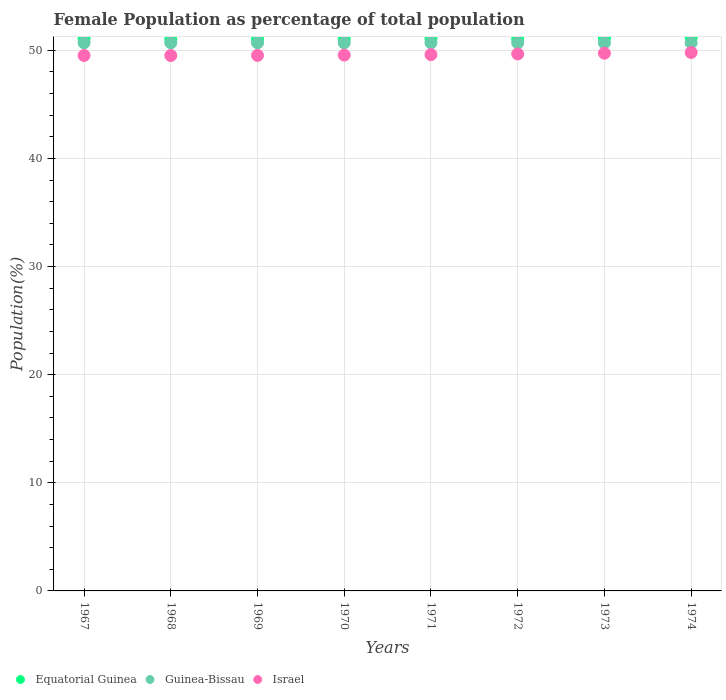How many different coloured dotlines are there?
Ensure brevity in your answer.  3. What is the female population in in Guinea-Bissau in 1967?
Provide a short and direct response. 50.69. Across all years, what is the maximum female population in in Guinea-Bissau?
Keep it short and to the point. 50.7. Across all years, what is the minimum female population in in Equatorial Guinea?
Ensure brevity in your answer.  51.02. In which year was the female population in in Equatorial Guinea maximum?
Provide a short and direct response. 1974. In which year was the female population in in Equatorial Guinea minimum?
Make the answer very short. 1968. What is the total female population in in Israel in the graph?
Your answer should be very brief. 396.96. What is the difference between the female population in in Israel in 1972 and that in 1973?
Offer a terse response. -0.07. What is the difference between the female population in in Guinea-Bissau in 1968 and the female population in in Israel in 1974?
Offer a very short reply. 0.89. What is the average female population in in Equatorial Guinea per year?
Your answer should be compact. 51.07. In the year 1967, what is the difference between the female population in in Equatorial Guinea and female population in in Guinea-Bissau?
Keep it short and to the point. 0.33. What is the ratio of the female population in in Guinea-Bissau in 1968 to that in 1974?
Provide a succinct answer. 1. What is the difference between the highest and the second highest female population in in Equatorial Guinea?
Your answer should be very brief. 0.06. What is the difference between the highest and the lowest female population in in Equatorial Guinea?
Offer a terse response. 0.18. In how many years, is the female population in in Israel greater than the average female population in in Israel taken over all years?
Your answer should be compact. 3. Is the sum of the female population in in Guinea-Bissau in 1970 and 1974 greater than the maximum female population in in Equatorial Guinea across all years?
Your answer should be very brief. Yes. Is the female population in in Guinea-Bissau strictly greater than the female population in in Israel over the years?
Your answer should be very brief. Yes. Is the female population in in Israel strictly less than the female population in in Guinea-Bissau over the years?
Offer a terse response. Yes. How many dotlines are there?
Keep it short and to the point. 3. Does the graph contain any zero values?
Give a very brief answer. No. Does the graph contain grids?
Give a very brief answer. Yes. Where does the legend appear in the graph?
Your response must be concise. Bottom left. How many legend labels are there?
Ensure brevity in your answer.  3. What is the title of the graph?
Your answer should be very brief. Female Population as percentage of total population. What is the label or title of the Y-axis?
Keep it short and to the point. Population(%). What is the Population(%) of Equatorial Guinea in 1967?
Provide a short and direct response. 51.02. What is the Population(%) in Guinea-Bissau in 1967?
Offer a terse response. 50.69. What is the Population(%) in Israel in 1967?
Offer a very short reply. 49.52. What is the Population(%) of Equatorial Guinea in 1968?
Make the answer very short. 51.02. What is the Population(%) of Guinea-Bissau in 1968?
Provide a short and direct response. 50.7. What is the Population(%) of Israel in 1968?
Offer a terse response. 49.52. What is the Population(%) of Equatorial Guinea in 1969?
Make the answer very short. 51.02. What is the Population(%) in Guinea-Bissau in 1969?
Offer a very short reply. 50.7. What is the Population(%) in Israel in 1969?
Provide a succinct answer. 49.53. What is the Population(%) in Equatorial Guinea in 1970?
Your answer should be compact. 51.03. What is the Population(%) of Guinea-Bissau in 1970?
Offer a terse response. 50.7. What is the Population(%) of Israel in 1970?
Ensure brevity in your answer.  49.56. What is the Population(%) in Equatorial Guinea in 1971?
Provide a succinct answer. 51.05. What is the Population(%) of Guinea-Bissau in 1971?
Give a very brief answer. 50.7. What is the Population(%) in Israel in 1971?
Your answer should be compact. 49.61. What is the Population(%) of Equatorial Guinea in 1972?
Ensure brevity in your answer.  51.08. What is the Population(%) in Guinea-Bissau in 1972?
Provide a short and direct response. 50.69. What is the Population(%) of Israel in 1972?
Your answer should be compact. 49.67. What is the Population(%) of Equatorial Guinea in 1973?
Provide a short and direct response. 51.13. What is the Population(%) of Guinea-Bissau in 1973?
Offer a terse response. 50.69. What is the Population(%) in Israel in 1973?
Your response must be concise. 49.74. What is the Population(%) in Equatorial Guinea in 1974?
Keep it short and to the point. 51.19. What is the Population(%) of Guinea-Bissau in 1974?
Ensure brevity in your answer.  50.69. What is the Population(%) in Israel in 1974?
Offer a very short reply. 49.8. Across all years, what is the maximum Population(%) in Equatorial Guinea?
Ensure brevity in your answer.  51.19. Across all years, what is the maximum Population(%) in Guinea-Bissau?
Offer a very short reply. 50.7. Across all years, what is the maximum Population(%) in Israel?
Your response must be concise. 49.8. Across all years, what is the minimum Population(%) of Equatorial Guinea?
Give a very brief answer. 51.02. Across all years, what is the minimum Population(%) in Guinea-Bissau?
Provide a short and direct response. 50.69. Across all years, what is the minimum Population(%) of Israel?
Your answer should be very brief. 49.52. What is the total Population(%) in Equatorial Guinea in the graph?
Ensure brevity in your answer.  408.55. What is the total Population(%) in Guinea-Bissau in the graph?
Provide a short and direct response. 405.55. What is the total Population(%) of Israel in the graph?
Provide a short and direct response. 396.96. What is the difference between the Population(%) in Equatorial Guinea in 1967 and that in 1968?
Your answer should be compact. 0.01. What is the difference between the Population(%) in Guinea-Bissau in 1967 and that in 1968?
Give a very brief answer. -0. What is the difference between the Population(%) of Israel in 1967 and that in 1968?
Your answer should be very brief. 0. What is the difference between the Population(%) in Equatorial Guinea in 1967 and that in 1969?
Your response must be concise. 0.01. What is the difference between the Population(%) of Guinea-Bissau in 1967 and that in 1969?
Make the answer very short. -0. What is the difference between the Population(%) in Israel in 1967 and that in 1969?
Provide a short and direct response. -0.01. What is the difference between the Population(%) in Equatorial Guinea in 1967 and that in 1970?
Provide a succinct answer. -0.01. What is the difference between the Population(%) of Guinea-Bissau in 1967 and that in 1970?
Provide a short and direct response. -0. What is the difference between the Population(%) in Israel in 1967 and that in 1970?
Provide a succinct answer. -0.04. What is the difference between the Population(%) of Equatorial Guinea in 1967 and that in 1971?
Your answer should be very brief. -0.03. What is the difference between the Population(%) in Guinea-Bissau in 1967 and that in 1971?
Give a very brief answer. -0. What is the difference between the Population(%) of Israel in 1967 and that in 1971?
Provide a short and direct response. -0.08. What is the difference between the Population(%) of Equatorial Guinea in 1967 and that in 1972?
Your answer should be compact. -0.06. What is the difference between the Population(%) of Guinea-Bissau in 1967 and that in 1972?
Make the answer very short. 0. What is the difference between the Population(%) of Israel in 1967 and that in 1972?
Your answer should be compact. -0.14. What is the difference between the Population(%) in Equatorial Guinea in 1967 and that in 1973?
Your response must be concise. -0.1. What is the difference between the Population(%) in Guinea-Bissau in 1967 and that in 1973?
Your response must be concise. 0. What is the difference between the Population(%) of Israel in 1967 and that in 1973?
Keep it short and to the point. -0.21. What is the difference between the Population(%) in Equatorial Guinea in 1967 and that in 1974?
Offer a very short reply. -0.17. What is the difference between the Population(%) in Guinea-Bissau in 1967 and that in 1974?
Provide a succinct answer. 0.01. What is the difference between the Population(%) of Israel in 1967 and that in 1974?
Keep it short and to the point. -0.28. What is the difference between the Population(%) of Equatorial Guinea in 1968 and that in 1969?
Provide a succinct answer. -0. What is the difference between the Population(%) in Guinea-Bissau in 1968 and that in 1969?
Offer a very short reply. -0. What is the difference between the Population(%) of Israel in 1968 and that in 1969?
Keep it short and to the point. -0.01. What is the difference between the Population(%) in Equatorial Guinea in 1968 and that in 1970?
Your answer should be compact. -0.01. What is the difference between the Population(%) of Guinea-Bissau in 1968 and that in 1970?
Provide a succinct answer. -0. What is the difference between the Population(%) of Israel in 1968 and that in 1970?
Your response must be concise. -0.04. What is the difference between the Population(%) in Equatorial Guinea in 1968 and that in 1971?
Provide a short and direct response. -0.04. What is the difference between the Population(%) of Israel in 1968 and that in 1971?
Your answer should be very brief. -0.09. What is the difference between the Population(%) of Equatorial Guinea in 1968 and that in 1972?
Offer a very short reply. -0.07. What is the difference between the Population(%) in Guinea-Bissau in 1968 and that in 1972?
Your answer should be very brief. 0. What is the difference between the Population(%) of Israel in 1968 and that in 1972?
Your response must be concise. -0.15. What is the difference between the Population(%) in Equatorial Guinea in 1968 and that in 1973?
Make the answer very short. -0.11. What is the difference between the Population(%) in Guinea-Bissau in 1968 and that in 1973?
Keep it short and to the point. 0.01. What is the difference between the Population(%) of Israel in 1968 and that in 1973?
Provide a succinct answer. -0.21. What is the difference between the Population(%) in Equatorial Guinea in 1968 and that in 1974?
Provide a succinct answer. -0.18. What is the difference between the Population(%) in Guinea-Bissau in 1968 and that in 1974?
Give a very brief answer. 0.01. What is the difference between the Population(%) of Israel in 1968 and that in 1974?
Offer a terse response. -0.28. What is the difference between the Population(%) of Equatorial Guinea in 1969 and that in 1970?
Ensure brevity in your answer.  -0.01. What is the difference between the Population(%) in Israel in 1969 and that in 1970?
Ensure brevity in your answer.  -0.03. What is the difference between the Population(%) of Equatorial Guinea in 1969 and that in 1971?
Offer a terse response. -0.04. What is the difference between the Population(%) of Guinea-Bissau in 1969 and that in 1971?
Make the answer very short. 0. What is the difference between the Population(%) in Israel in 1969 and that in 1971?
Give a very brief answer. -0.08. What is the difference between the Population(%) in Equatorial Guinea in 1969 and that in 1972?
Provide a succinct answer. -0.07. What is the difference between the Population(%) of Guinea-Bissau in 1969 and that in 1972?
Give a very brief answer. 0. What is the difference between the Population(%) of Israel in 1969 and that in 1972?
Provide a short and direct response. -0.14. What is the difference between the Population(%) of Equatorial Guinea in 1969 and that in 1973?
Make the answer very short. -0.11. What is the difference between the Population(%) in Guinea-Bissau in 1969 and that in 1973?
Your response must be concise. 0.01. What is the difference between the Population(%) in Israel in 1969 and that in 1973?
Keep it short and to the point. -0.2. What is the difference between the Population(%) in Equatorial Guinea in 1969 and that in 1974?
Your answer should be compact. -0.17. What is the difference between the Population(%) in Guinea-Bissau in 1969 and that in 1974?
Your answer should be very brief. 0.01. What is the difference between the Population(%) of Israel in 1969 and that in 1974?
Your answer should be very brief. -0.27. What is the difference between the Population(%) in Equatorial Guinea in 1970 and that in 1971?
Provide a short and direct response. -0.02. What is the difference between the Population(%) in Guinea-Bissau in 1970 and that in 1971?
Your answer should be compact. 0. What is the difference between the Population(%) in Israel in 1970 and that in 1971?
Your response must be concise. -0.05. What is the difference between the Population(%) of Equatorial Guinea in 1970 and that in 1972?
Provide a short and direct response. -0.05. What is the difference between the Population(%) in Guinea-Bissau in 1970 and that in 1972?
Your answer should be compact. 0. What is the difference between the Population(%) in Israel in 1970 and that in 1972?
Give a very brief answer. -0.11. What is the difference between the Population(%) in Equatorial Guinea in 1970 and that in 1973?
Provide a short and direct response. -0.1. What is the difference between the Population(%) in Guinea-Bissau in 1970 and that in 1973?
Offer a very short reply. 0.01. What is the difference between the Population(%) of Israel in 1970 and that in 1973?
Ensure brevity in your answer.  -0.17. What is the difference between the Population(%) in Equatorial Guinea in 1970 and that in 1974?
Give a very brief answer. -0.16. What is the difference between the Population(%) of Guinea-Bissau in 1970 and that in 1974?
Make the answer very short. 0.01. What is the difference between the Population(%) in Israel in 1970 and that in 1974?
Your answer should be very brief. -0.24. What is the difference between the Population(%) in Equatorial Guinea in 1971 and that in 1972?
Ensure brevity in your answer.  -0.03. What is the difference between the Population(%) of Guinea-Bissau in 1971 and that in 1972?
Give a very brief answer. 0. What is the difference between the Population(%) of Israel in 1971 and that in 1972?
Ensure brevity in your answer.  -0.06. What is the difference between the Population(%) of Equatorial Guinea in 1971 and that in 1973?
Your answer should be compact. -0.07. What is the difference between the Population(%) in Guinea-Bissau in 1971 and that in 1973?
Provide a short and direct response. 0.01. What is the difference between the Population(%) in Israel in 1971 and that in 1973?
Provide a short and direct response. -0.13. What is the difference between the Population(%) of Equatorial Guinea in 1971 and that in 1974?
Offer a very short reply. -0.14. What is the difference between the Population(%) in Guinea-Bissau in 1971 and that in 1974?
Offer a terse response. 0.01. What is the difference between the Population(%) of Israel in 1971 and that in 1974?
Your answer should be compact. -0.19. What is the difference between the Population(%) of Equatorial Guinea in 1972 and that in 1973?
Keep it short and to the point. -0.04. What is the difference between the Population(%) in Guinea-Bissau in 1972 and that in 1973?
Provide a succinct answer. 0. What is the difference between the Population(%) in Israel in 1972 and that in 1973?
Offer a terse response. -0.07. What is the difference between the Population(%) in Equatorial Guinea in 1972 and that in 1974?
Make the answer very short. -0.11. What is the difference between the Population(%) in Guinea-Bissau in 1972 and that in 1974?
Your answer should be compact. 0.01. What is the difference between the Population(%) in Israel in 1972 and that in 1974?
Your answer should be very brief. -0.13. What is the difference between the Population(%) of Equatorial Guinea in 1973 and that in 1974?
Make the answer very short. -0.06. What is the difference between the Population(%) in Guinea-Bissau in 1973 and that in 1974?
Make the answer very short. 0. What is the difference between the Population(%) of Israel in 1973 and that in 1974?
Offer a terse response. -0.07. What is the difference between the Population(%) of Equatorial Guinea in 1967 and the Population(%) of Guinea-Bissau in 1968?
Your response must be concise. 0.33. What is the difference between the Population(%) in Equatorial Guinea in 1967 and the Population(%) in Israel in 1968?
Provide a short and direct response. 1.5. What is the difference between the Population(%) of Guinea-Bissau in 1967 and the Population(%) of Israel in 1968?
Your answer should be very brief. 1.17. What is the difference between the Population(%) in Equatorial Guinea in 1967 and the Population(%) in Guinea-Bissau in 1969?
Make the answer very short. 0.33. What is the difference between the Population(%) in Equatorial Guinea in 1967 and the Population(%) in Israel in 1969?
Keep it short and to the point. 1.49. What is the difference between the Population(%) of Guinea-Bissau in 1967 and the Population(%) of Israel in 1969?
Your answer should be compact. 1.16. What is the difference between the Population(%) of Equatorial Guinea in 1967 and the Population(%) of Guinea-Bissau in 1970?
Offer a terse response. 0.33. What is the difference between the Population(%) in Equatorial Guinea in 1967 and the Population(%) in Israel in 1970?
Your answer should be very brief. 1.46. What is the difference between the Population(%) in Guinea-Bissau in 1967 and the Population(%) in Israel in 1970?
Give a very brief answer. 1.13. What is the difference between the Population(%) in Equatorial Guinea in 1967 and the Population(%) in Guinea-Bissau in 1971?
Your response must be concise. 0.33. What is the difference between the Population(%) in Equatorial Guinea in 1967 and the Population(%) in Israel in 1971?
Give a very brief answer. 1.42. What is the difference between the Population(%) in Guinea-Bissau in 1967 and the Population(%) in Israel in 1971?
Your response must be concise. 1.09. What is the difference between the Population(%) in Equatorial Guinea in 1967 and the Population(%) in Guinea-Bissau in 1972?
Keep it short and to the point. 0.33. What is the difference between the Population(%) of Equatorial Guinea in 1967 and the Population(%) of Israel in 1972?
Make the answer very short. 1.36. What is the difference between the Population(%) in Guinea-Bissau in 1967 and the Population(%) in Israel in 1972?
Your answer should be compact. 1.03. What is the difference between the Population(%) in Equatorial Guinea in 1967 and the Population(%) in Guinea-Bissau in 1973?
Offer a very short reply. 0.33. What is the difference between the Population(%) in Equatorial Guinea in 1967 and the Population(%) in Israel in 1973?
Your response must be concise. 1.29. What is the difference between the Population(%) of Guinea-Bissau in 1967 and the Population(%) of Israel in 1973?
Offer a very short reply. 0.96. What is the difference between the Population(%) of Equatorial Guinea in 1967 and the Population(%) of Guinea-Bissau in 1974?
Offer a very short reply. 0.34. What is the difference between the Population(%) of Equatorial Guinea in 1967 and the Population(%) of Israel in 1974?
Your answer should be compact. 1.22. What is the difference between the Population(%) in Guinea-Bissau in 1967 and the Population(%) in Israel in 1974?
Keep it short and to the point. 0.89. What is the difference between the Population(%) in Equatorial Guinea in 1968 and the Population(%) in Guinea-Bissau in 1969?
Your answer should be compact. 0.32. What is the difference between the Population(%) in Equatorial Guinea in 1968 and the Population(%) in Israel in 1969?
Your answer should be compact. 1.48. What is the difference between the Population(%) of Guinea-Bissau in 1968 and the Population(%) of Israel in 1969?
Your answer should be very brief. 1.16. What is the difference between the Population(%) in Equatorial Guinea in 1968 and the Population(%) in Guinea-Bissau in 1970?
Ensure brevity in your answer.  0.32. What is the difference between the Population(%) in Equatorial Guinea in 1968 and the Population(%) in Israel in 1970?
Keep it short and to the point. 1.45. What is the difference between the Population(%) of Guinea-Bissau in 1968 and the Population(%) of Israel in 1970?
Your answer should be very brief. 1.13. What is the difference between the Population(%) of Equatorial Guinea in 1968 and the Population(%) of Guinea-Bissau in 1971?
Provide a succinct answer. 0.32. What is the difference between the Population(%) of Equatorial Guinea in 1968 and the Population(%) of Israel in 1971?
Keep it short and to the point. 1.41. What is the difference between the Population(%) of Guinea-Bissau in 1968 and the Population(%) of Israel in 1971?
Provide a short and direct response. 1.09. What is the difference between the Population(%) of Equatorial Guinea in 1968 and the Population(%) of Guinea-Bissau in 1972?
Your response must be concise. 0.32. What is the difference between the Population(%) of Equatorial Guinea in 1968 and the Population(%) of Israel in 1972?
Provide a succinct answer. 1.35. What is the difference between the Population(%) of Guinea-Bissau in 1968 and the Population(%) of Israel in 1972?
Provide a short and direct response. 1.03. What is the difference between the Population(%) of Equatorial Guinea in 1968 and the Population(%) of Guinea-Bissau in 1973?
Offer a very short reply. 0.33. What is the difference between the Population(%) in Equatorial Guinea in 1968 and the Population(%) in Israel in 1973?
Ensure brevity in your answer.  1.28. What is the difference between the Population(%) of Guinea-Bissau in 1968 and the Population(%) of Israel in 1973?
Provide a short and direct response. 0.96. What is the difference between the Population(%) in Equatorial Guinea in 1968 and the Population(%) in Guinea-Bissau in 1974?
Ensure brevity in your answer.  0.33. What is the difference between the Population(%) in Equatorial Guinea in 1968 and the Population(%) in Israel in 1974?
Provide a short and direct response. 1.21. What is the difference between the Population(%) in Guinea-Bissau in 1968 and the Population(%) in Israel in 1974?
Give a very brief answer. 0.89. What is the difference between the Population(%) of Equatorial Guinea in 1969 and the Population(%) of Guinea-Bissau in 1970?
Make the answer very short. 0.32. What is the difference between the Population(%) in Equatorial Guinea in 1969 and the Population(%) in Israel in 1970?
Provide a short and direct response. 1.45. What is the difference between the Population(%) of Guinea-Bissau in 1969 and the Population(%) of Israel in 1970?
Offer a terse response. 1.14. What is the difference between the Population(%) in Equatorial Guinea in 1969 and the Population(%) in Guinea-Bissau in 1971?
Offer a terse response. 0.32. What is the difference between the Population(%) of Equatorial Guinea in 1969 and the Population(%) of Israel in 1971?
Your answer should be very brief. 1.41. What is the difference between the Population(%) of Guinea-Bissau in 1969 and the Population(%) of Israel in 1971?
Offer a very short reply. 1.09. What is the difference between the Population(%) of Equatorial Guinea in 1969 and the Population(%) of Guinea-Bissau in 1972?
Offer a very short reply. 0.32. What is the difference between the Population(%) of Equatorial Guinea in 1969 and the Population(%) of Israel in 1972?
Ensure brevity in your answer.  1.35. What is the difference between the Population(%) of Guinea-Bissau in 1969 and the Population(%) of Israel in 1972?
Give a very brief answer. 1.03. What is the difference between the Population(%) in Equatorial Guinea in 1969 and the Population(%) in Guinea-Bissau in 1973?
Provide a succinct answer. 0.33. What is the difference between the Population(%) in Equatorial Guinea in 1969 and the Population(%) in Israel in 1973?
Give a very brief answer. 1.28. What is the difference between the Population(%) in Equatorial Guinea in 1969 and the Population(%) in Guinea-Bissau in 1974?
Offer a very short reply. 0.33. What is the difference between the Population(%) in Equatorial Guinea in 1969 and the Population(%) in Israel in 1974?
Keep it short and to the point. 1.21. What is the difference between the Population(%) in Guinea-Bissau in 1969 and the Population(%) in Israel in 1974?
Provide a short and direct response. 0.89. What is the difference between the Population(%) in Equatorial Guinea in 1970 and the Population(%) in Guinea-Bissau in 1971?
Provide a succinct answer. 0.33. What is the difference between the Population(%) of Equatorial Guinea in 1970 and the Population(%) of Israel in 1971?
Give a very brief answer. 1.42. What is the difference between the Population(%) of Guinea-Bissau in 1970 and the Population(%) of Israel in 1971?
Your answer should be compact. 1.09. What is the difference between the Population(%) of Equatorial Guinea in 1970 and the Population(%) of Guinea-Bissau in 1972?
Keep it short and to the point. 0.34. What is the difference between the Population(%) of Equatorial Guinea in 1970 and the Population(%) of Israel in 1972?
Make the answer very short. 1.36. What is the difference between the Population(%) in Guinea-Bissau in 1970 and the Population(%) in Israel in 1972?
Keep it short and to the point. 1.03. What is the difference between the Population(%) of Equatorial Guinea in 1970 and the Population(%) of Guinea-Bissau in 1973?
Give a very brief answer. 0.34. What is the difference between the Population(%) of Equatorial Guinea in 1970 and the Population(%) of Israel in 1973?
Give a very brief answer. 1.29. What is the difference between the Population(%) in Guinea-Bissau in 1970 and the Population(%) in Israel in 1973?
Your response must be concise. 0.96. What is the difference between the Population(%) of Equatorial Guinea in 1970 and the Population(%) of Guinea-Bissau in 1974?
Offer a terse response. 0.34. What is the difference between the Population(%) in Equatorial Guinea in 1970 and the Population(%) in Israel in 1974?
Offer a very short reply. 1.23. What is the difference between the Population(%) in Guinea-Bissau in 1970 and the Population(%) in Israel in 1974?
Provide a succinct answer. 0.89. What is the difference between the Population(%) in Equatorial Guinea in 1971 and the Population(%) in Guinea-Bissau in 1972?
Offer a very short reply. 0.36. What is the difference between the Population(%) in Equatorial Guinea in 1971 and the Population(%) in Israel in 1972?
Offer a terse response. 1.39. What is the difference between the Population(%) of Guinea-Bissau in 1971 and the Population(%) of Israel in 1972?
Provide a succinct answer. 1.03. What is the difference between the Population(%) of Equatorial Guinea in 1971 and the Population(%) of Guinea-Bissau in 1973?
Make the answer very short. 0.36. What is the difference between the Population(%) of Equatorial Guinea in 1971 and the Population(%) of Israel in 1973?
Ensure brevity in your answer.  1.32. What is the difference between the Population(%) in Guinea-Bissau in 1971 and the Population(%) in Israel in 1973?
Your response must be concise. 0.96. What is the difference between the Population(%) of Equatorial Guinea in 1971 and the Population(%) of Guinea-Bissau in 1974?
Offer a very short reply. 0.37. What is the difference between the Population(%) of Equatorial Guinea in 1971 and the Population(%) of Israel in 1974?
Offer a very short reply. 1.25. What is the difference between the Population(%) in Guinea-Bissau in 1971 and the Population(%) in Israel in 1974?
Provide a succinct answer. 0.89. What is the difference between the Population(%) of Equatorial Guinea in 1972 and the Population(%) of Guinea-Bissau in 1973?
Your answer should be very brief. 0.39. What is the difference between the Population(%) of Equatorial Guinea in 1972 and the Population(%) of Israel in 1973?
Offer a terse response. 1.35. What is the difference between the Population(%) of Guinea-Bissau in 1972 and the Population(%) of Israel in 1973?
Offer a very short reply. 0.96. What is the difference between the Population(%) in Equatorial Guinea in 1972 and the Population(%) in Guinea-Bissau in 1974?
Provide a short and direct response. 0.4. What is the difference between the Population(%) of Equatorial Guinea in 1972 and the Population(%) of Israel in 1974?
Make the answer very short. 1.28. What is the difference between the Population(%) of Guinea-Bissau in 1972 and the Population(%) of Israel in 1974?
Ensure brevity in your answer.  0.89. What is the difference between the Population(%) in Equatorial Guinea in 1973 and the Population(%) in Guinea-Bissau in 1974?
Ensure brevity in your answer.  0.44. What is the difference between the Population(%) in Equatorial Guinea in 1973 and the Population(%) in Israel in 1974?
Your response must be concise. 1.33. What is the difference between the Population(%) of Guinea-Bissau in 1973 and the Population(%) of Israel in 1974?
Give a very brief answer. 0.89. What is the average Population(%) in Equatorial Guinea per year?
Keep it short and to the point. 51.07. What is the average Population(%) in Guinea-Bissau per year?
Give a very brief answer. 50.69. What is the average Population(%) of Israel per year?
Offer a terse response. 49.62. In the year 1967, what is the difference between the Population(%) in Equatorial Guinea and Population(%) in Guinea-Bissau?
Offer a very short reply. 0.33. In the year 1967, what is the difference between the Population(%) in Equatorial Guinea and Population(%) in Israel?
Provide a succinct answer. 1.5. In the year 1967, what is the difference between the Population(%) in Guinea-Bissau and Population(%) in Israel?
Give a very brief answer. 1.17. In the year 1968, what is the difference between the Population(%) in Equatorial Guinea and Population(%) in Guinea-Bissau?
Your response must be concise. 0.32. In the year 1968, what is the difference between the Population(%) of Equatorial Guinea and Population(%) of Israel?
Ensure brevity in your answer.  1.49. In the year 1968, what is the difference between the Population(%) of Guinea-Bissau and Population(%) of Israel?
Provide a succinct answer. 1.17. In the year 1969, what is the difference between the Population(%) in Equatorial Guinea and Population(%) in Guinea-Bissau?
Provide a succinct answer. 0.32. In the year 1969, what is the difference between the Population(%) of Equatorial Guinea and Population(%) of Israel?
Your response must be concise. 1.48. In the year 1969, what is the difference between the Population(%) in Guinea-Bissau and Population(%) in Israel?
Ensure brevity in your answer.  1.16. In the year 1970, what is the difference between the Population(%) in Equatorial Guinea and Population(%) in Guinea-Bissau?
Ensure brevity in your answer.  0.33. In the year 1970, what is the difference between the Population(%) of Equatorial Guinea and Population(%) of Israel?
Offer a very short reply. 1.47. In the year 1970, what is the difference between the Population(%) in Guinea-Bissau and Population(%) in Israel?
Provide a succinct answer. 1.14. In the year 1971, what is the difference between the Population(%) of Equatorial Guinea and Population(%) of Guinea-Bissau?
Provide a succinct answer. 0.36. In the year 1971, what is the difference between the Population(%) in Equatorial Guinea and Population(%) in Israel?
Offer a terse response. 1.45. In the year 1971, what is the difference between the Population(%) in Guinea-Bissau and Population(%) in Israel?
Offer a very short reply. 1.09. In the year 1972, what is the difference between the Population(%) in Equatorial Guinea and Population(%) in Guinea-Bissau?
Provide a succinct answer. 0.39. In the year 1972, what is the difference between the Population(%) in Equatorial Guinea and Population(%) in Israel?
Give a very brief answer. 1.42. In the year 1972, what is the difference between the Population(%) in Guinea-Bissau and Population(%) in Israel?
Your response must be concise. 1.02. In the year 1973, what is the difference between the Population(%) in Equatorial Guinea and Population(%) in Guinea-Bissau?
Give a very brief answer. 0.44. In the year 1973, what is the difference between the Population(%) of Equatorial Guinea and Population(%) of Israel?
Keep it short and to the point. 1.39. In the year 1973, what is the difference between the Population(%) in Guinea-Bissau and Population(%) in Israel?
Offer a terse response. 0.95. In the year 1974, what is the difference between the Population(%) in Equatorial Guinea and Population(%) in Guinea-Bissau?
Your answer should be very brief. 0.51. In the year 1974, what is the difference between the Population(%) in Equatorial Guinea and Population(%) in Israel?
Give a very brief answer. 1.39. In the year 1974, what is the difference between the Population(%) of Guinea-Bissau and Population(%) of Israel?
Offer a very short reply. 0.88. What is the ratio of the Population(%) in Equatorial Guinea in 1967 to that in 1968?
Offer a terse response. 1. What is the ratio of the Population(%) in Equatorial Guinea in 1967 to that in 1969?
Provide a short and direct response. 1. What is the ratio of the Population(%) in Equatorial Guinea in 1967 to that in 1970?
Your answer should be compact. 1. What is the ratio of the Population(%) of Guinea-Bissau in 1967 to that in 1970?
Ensure brevity in your answer.  1. What is the ratio of the Population(%) in Equatorial Guinea in 1967 to that in 1971?
Your answer should be compact. 1. What is the ratio of the Population(%) in Equatorial Guinea in 1967 to that in 1972?
Ensure brevity in your answer.  1. What is the ratio of the Population(%) of Guinea-Bissau in 1967 to that in 1972?
Provide a succinct answer. 1. What is the ratio of the Population(%) in Equatorial Guinea in 1967 to that in 1973?
Your answer should be compact. 1. What is the ratio of the Population(%) of Israel in 1967 to that in 1973?
Offer a terse response. 1. What is the ratio of the Population(%) in Equatorial Guinea in 1968 to that in 1969?
Give a very brief answer. 1. What is the ratio of the Population(%) in Guinea-Bissau in 1968 to that in 1969?
Give a very brief answer. 1. What is the ratio of the Population(%) in Israel in 1968 to that in 1970?
Offer a terse response. 1. What is the ratio of the Population(%) in Guinea-Bissau in 1968 to that in 1972?
Your answer should be compact. 1. What is the ratio of the Population(%) of Equatorial Guinea in 1968 to that in 1973?
Keep it short and to the point. 1. What is the ratio of the Population(%) in Guinea-Bissau in 1968 to that in 1973?
Keep it short and to the point. 1. What is the ratio of the Population(%) in Equatorial Guinea in 1968 to that in 1974?
Provide a short and direct response. 1. What is the ratio of the Population(%) of Guinea-Bissau in 1968 to that in 1974?
Provide a succinct answer. 1. What is the ratio of the Population(%) in Israel in 1968 to that in 1974?
Your answer should be very brief. 0.99. What is the ratio of the Population(%) of Equatorial Guinea in 1969 to that in 1970?
Ensure brevity in your answer.  1. What is the ratio of the Population(%) in Guinea-Bissau in 1969 to that in 1971?
Make the answer very short. 1. What is the ratio of the Population(%) in Israel in 1969 to that in 1971?
Your answer should be compact. 1. What is the ratio of the Population(%) in Equatorial Guinea in 1969 to that in 1973?
Provide a short and direct response. 1. What is the ratio of the Population(%) in Guinea-Bissau in 1969 to that in 1973?
Keep it short and to the point. 1. What is the ratio of the Population(%) in Israel in 1969 to that in 1973?
Offer a very short reply. 1. What is the ratio of the Population(%) in Equatorial Guinea in 1969 to that in 1974?
Provide a short and direct response. 1. What is the ratio of the Population(%) of Guinea-Bissau in 1969 to that in 1974?
Ensure brevity in your answer.  1. What is the ratio of the Population(%) of Israel in 1970 to that in 1971?
Your response must be concise. 1. What is the ratio of the Population(%) in Equatorial Guinea in 1970 to that in 1972?
Your answer should be very brief. 1. What is the ratio of the Population(%) of Israel in 1970 to that in 1972?
Offer a terse response. 1. What is the ratio of the Population(%) of Guinea-Bissau in 1970 to that in 1973?
Give a very brief answer. 1. What is the ratio of the Population(%) in Israel in 1970 to that in 1973?
Your answer should be very brief. 1. What is the ratio of the Population(%) in Israel in 1970 to that in 1974?
Keep it short and to the point. 1. What is the ratio of the Population(%) of Israel in 1971 to that in 1972?
Your response must be concise. 1. What is the ratio of the Population(%) of Guinea-Bissau in 1971 to that in 1973?
Keep it short and to the point. 1. What is the ratio of the Population(%) of Equatorial Guinea in 1971 to that in 1974?
Ensure brevity in your answer.  1. What is the ratio of the Population(%) in Guinea-Bissau in 1971 to that in 1974?
Offer a terse response. 1. What is the ratio of the Population(%) of Israel in 1971 to that in 1974?
Give a very brief answer. 1. What is the ratio of the Population(%) in Israel in 1972 to that in 1973?
Offer a terse response. 1. What is the difference between the highest and the second highest Population(%) in Equatorial Guinea?
Offer a terse response. 0.06. What is the difference between the highest and the second highest Population(%) of Guinea-Bissau?
Your response must be concise. 0. What is the difference between the highest and the second highest Population(%) in Israel?
Make the answer very short. 0.07. What is the difference between the highest and the lowest Population(%) of Equatorial Guinea?
Your answer should be compact. 0.18. What is the difference between the highest and the lowest Population(%) of Guinea-Bissau?
Keep it short and to the point. 0.01. What is the difference between the highest and the lowest Population(%) in Israel?
Your response must be concise. 0.28. 